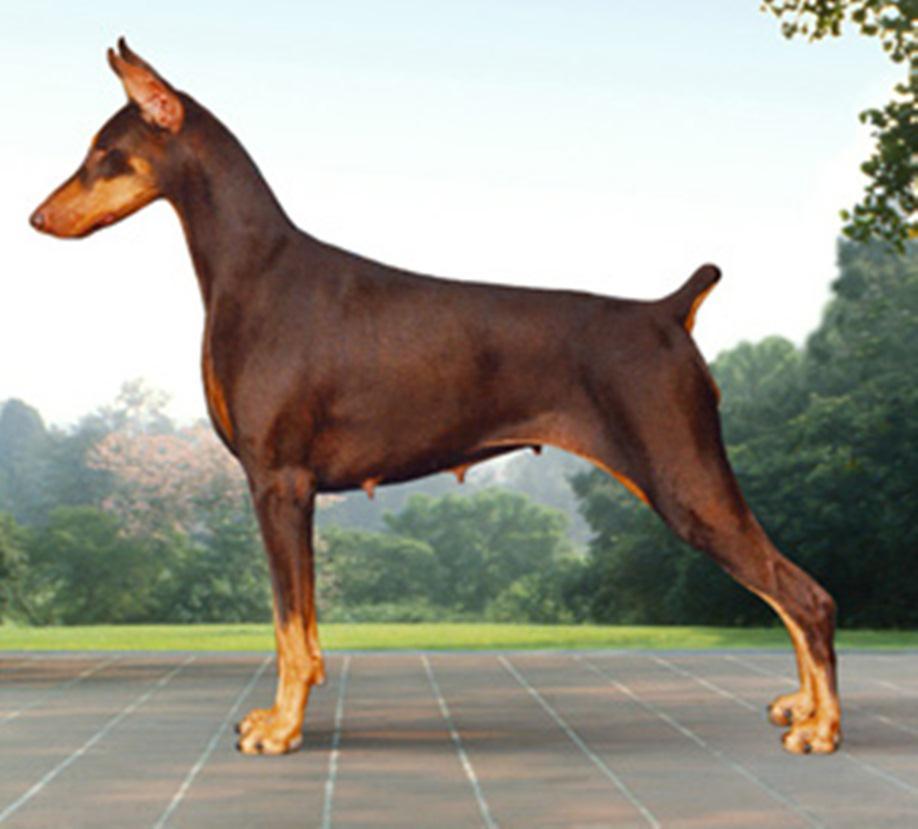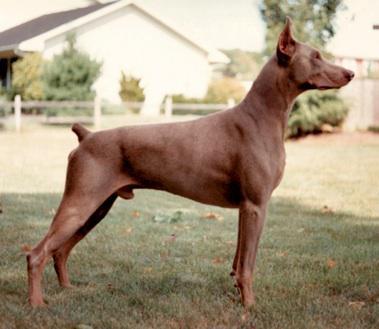The first image is the image on the left, the second image is the image on the right. Given the left and right images, does the statement "Each image shows one dog standing in profile, and the left image shows a brown dog, while the right image shows a right-facing doberman with pointy ears and docked tail." hold true? Answer yes or no. Yes. The first image is the image on the left, the second image is the image on the right. Assess this claim about the two images: "At least one dog is facing towards the left.". Correct or not? Answer yes or no. Yes. 